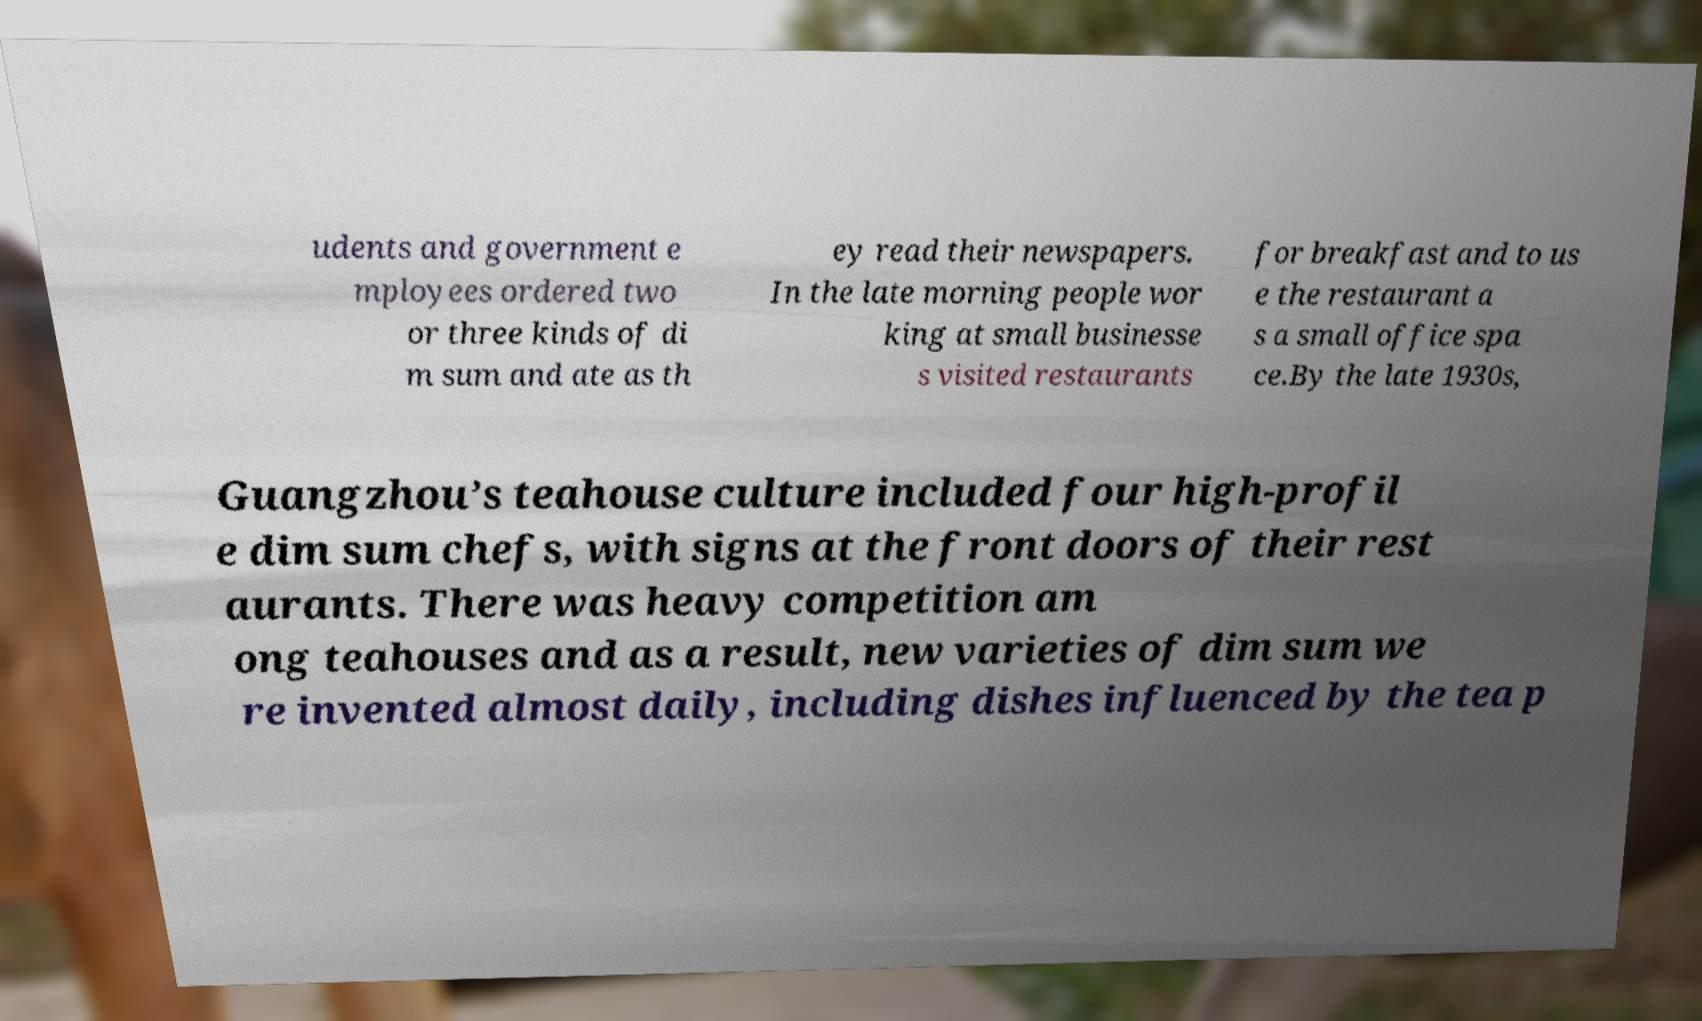Could you assist in decoding the text presented in this image and type it out clearly? udents and government e mployees ordered two or three kinds of di m sum and ate as th ey read their newspapers. In the late morning people wor king at small businesse s visited restaurants for breakfast and to us e the restaurant a s a small office spa ce.By the late 1930s, Guangzhou’s teahouse culture included four high-profil e dim sum chefs, with signs at the front doors of their rest aurants. There was heavy competition am ong teahouses and as a result, new varieties of dim sum we re invented almost daily, including dishes influenced by the tea p 